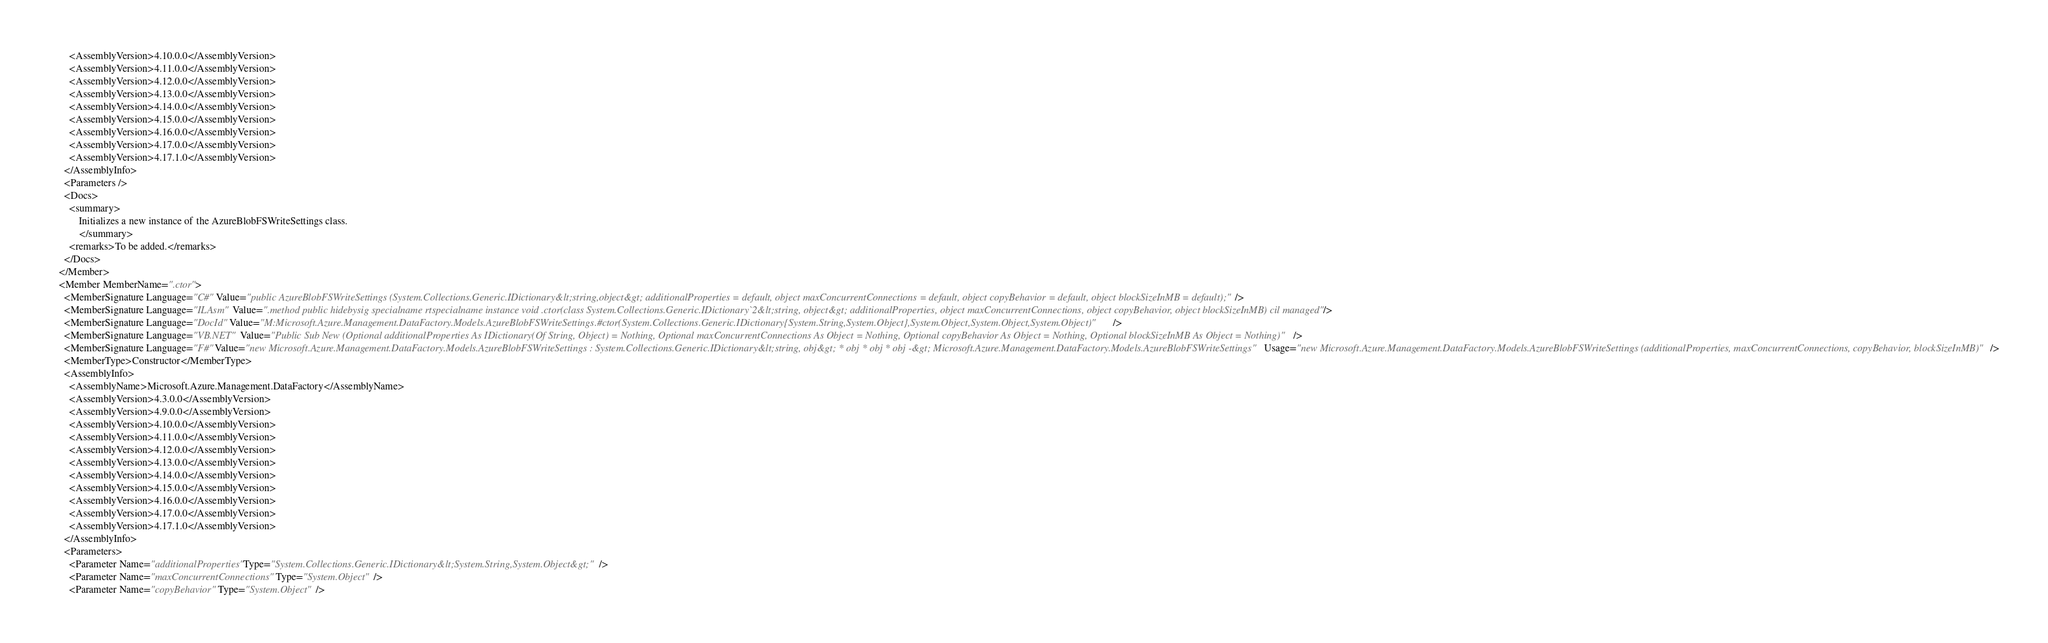Convert code to text. <code><loc_0><loc_0><loc_500><loc_500><_XML_>        <AssemblyVersion>4.10.0.0</AssemblyVersion>
        <AssemblyVersion>4.11.0.0</AssemblyVersion>
        <AssemblyVersion>4.12.0.0</AssemblyVersion>
        <AssemblyVersion>4.13.0.0</AssemblyVersion>
        <AssemblyVersion>4.14.0.0</AssemblyVersion>
        <AssemblyVersion>4.15.0.0</AssemblyVersion>
        <AssemblyVersion>4.16.0.0</AssemblyVersion>
        <AssemblyVersion>4.17.0.0</AssemblyVersion>
        <AssemblyVersion>4.17.1.0</AssemblyVersion>
      </AssemblyInfo>
      <Parameters />
      <Docs>
        <summary>
            Initializes a new instance of the AzureBlobFSWriteSettings class.
            </summary>
        <remarks>To be added.</remarks>
      </Docs>
    </Member>
    <Member MemberName=".ctor">
      <MemberSignature Language="C#" Value="public AzureBlobFSWriteSettings (System.Collections.Generic.IDictionary&lt;string,object&gt; additionalProperties = default, object maxConcurrentConnections = default, object copyBehavior = default, object blockSizeInMB = default);" />
      <MemberSignature Language="ILAsm" Value=".method public hidebysig specialname rtspecialname instance void .ctor(class System.Collections.Generic.IDictionary`2&lt;string, object&gt; additionalProperties, object maxConcurrentConnections, object copyBehavior, object blockSizeInMB) cil managed" />
      <MemberSignature Language="DocId" Value="M:Microsoft.Azure.Management.DataFactory.Models.AzureBlobFSWriteSettings.#ctor(System.Collections.Generic.IDictionary{System.String,System.Object},System.Object,System.Object,System.Object)" />
      <MemberSignature Language="VB.NET" Value="Public Sub New (Optional additionalProperties As IDictionary(Of String, Object) = Nothing, Optional maxConcurrentConnections As Object = Nothing, Optional copyBehavior As Object = Nothing, Optional blockSizeInMB As Object = Nothing)" />
      <MemberSignature Language="F#" Value="new Microsoft.Azure.Management.DataFactory.Models.AzureBlobFSWriteSettings : System.Collections.Generic.IDictionary&lt;string, obj&gt; * obj * obj * obj -&gt; Microsoft.Azure.Management.DataFactory.Models.AzureBlobFSWriteSettings" Usage="new Microsoft.Azure.Management.DataFactory.Models.AzureBlobFSWriteSettings (additionalProperties, maxConcurrentConnections, copyBehavior, blockSizeInMB)" />
      <MemberType>Constructor</MemberType>
      <AssemblyInfo>
        <AssemblyName>Microsoft.Azure.Management.DataFactory</AssemblyName>
        <AssemblyVersion>4.3.0.0</AssemblyVersion>
        <AssemblyVersion>4.9.0.0</AssemblyVersion>
        <AssemblyVersion>4.10.0.0</AssemblyVersion>
        <AssemblyVersion>4.11.0.0</AssemblyVersion>
        <AssemblyVersion>4.12.0.0</AssemblyVersion>
        <AssemblyVersion>4.13.0.0</AssemblyVersion>
        <AssemblyVersion>4.14.0.0</AssemblyVersion>
        <AssemblyVersion>4.15.0.0</AssemblyVersion>
        <AssemblyVersion>4.16.0.0</AssemblyVersion>
        <AssemblyVersion>4.17.0.0</AssemblyVersion>
        <AssemblyVersion>4.17.1.0</AssemblyVersion>
      </AssemblyInfo>
      <Parameters>
        <Parameter Name="additionalProperties" Type="System.Collections.Generic.IDictionary&lt;System.String,System.Object&gt;" />
        <Parameter Name="maxConcurrentConnections" Type="System.Object" />
        <Parameter Name="copyBehavior" Type="System.Object" /></code> 